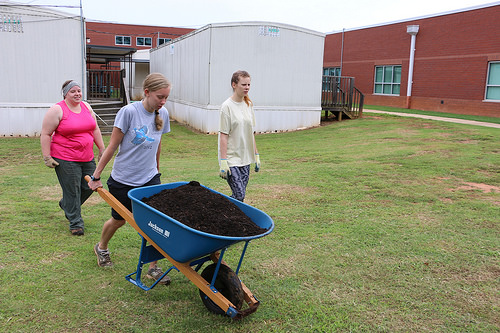<image>
Is there a wall behind the girl? Yes. From this viewpoint, the wall is positioned behind the girl, with the girl partially or fully occluding the wall. 